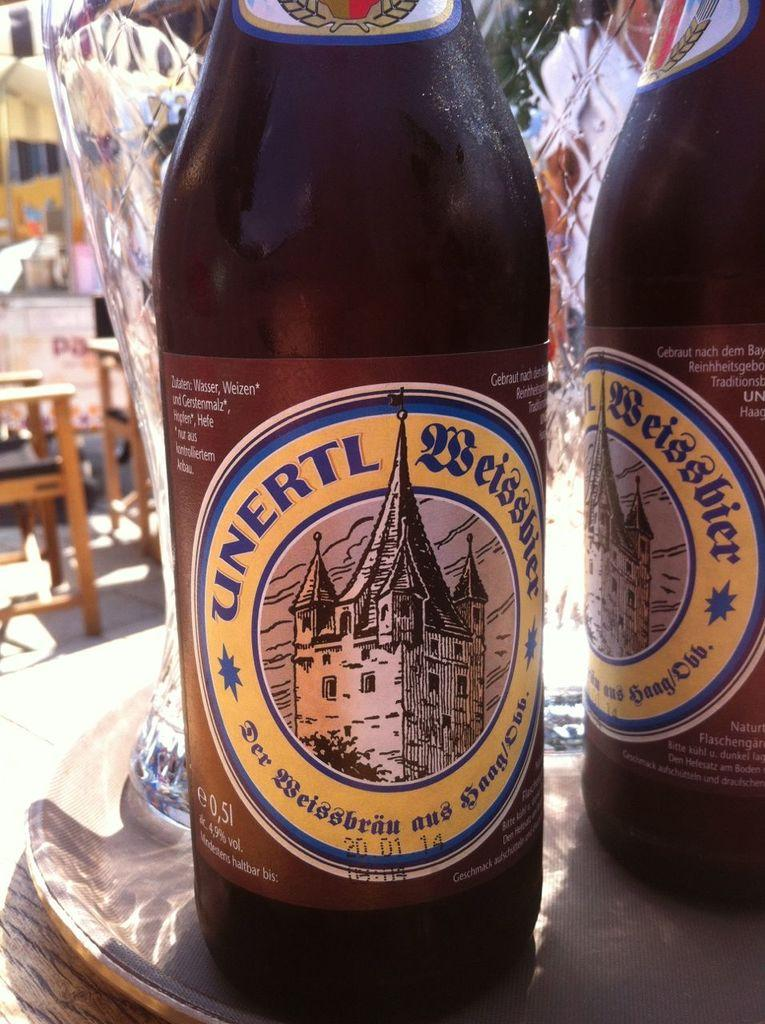<image>
Present a compact description of the photo's key features. Bottle with a label that says "Unertl" on it. 